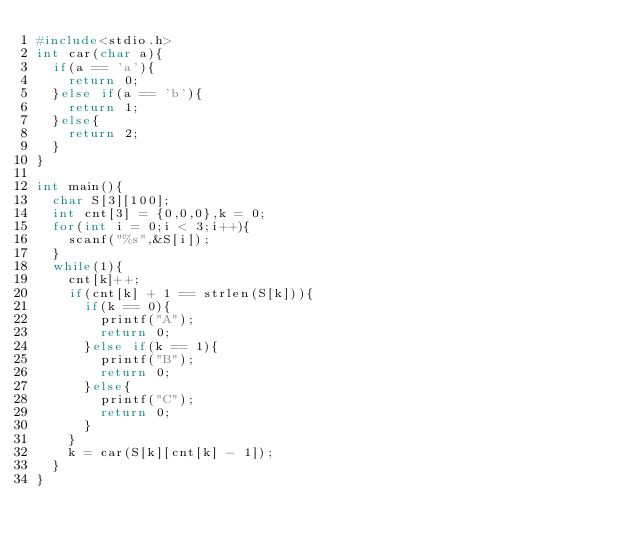Convert code to text. <code><loc_0><loc_0><loc_500><loc_500><_C_>#include<stdio.h>
int car(char a){
  if(a == 'a'){
    return 0;
  }else if(a == 'b'){
    return 1;
  }else{
    return 2;
  }
}

int main(){
  char S[3][100];
  int cnt[3] = {0,0,0},k = 0;
  for(int i = 0;i < 3;i++){
    scanf("%s",&S[i]);
  }
  while(1){
    cnt[k]++;
    if(cnt[k] + 1 == strlen(S[k])){
      if(k == 0){
        printf("A");
        return 0;
      }else if(k == 1){
        printf("B");
        return 0;
      }else{
        printf("C");
        return 0;
      }
    }
    k = car(S[k][cnt[k] - 1]);
  }
}</code> 